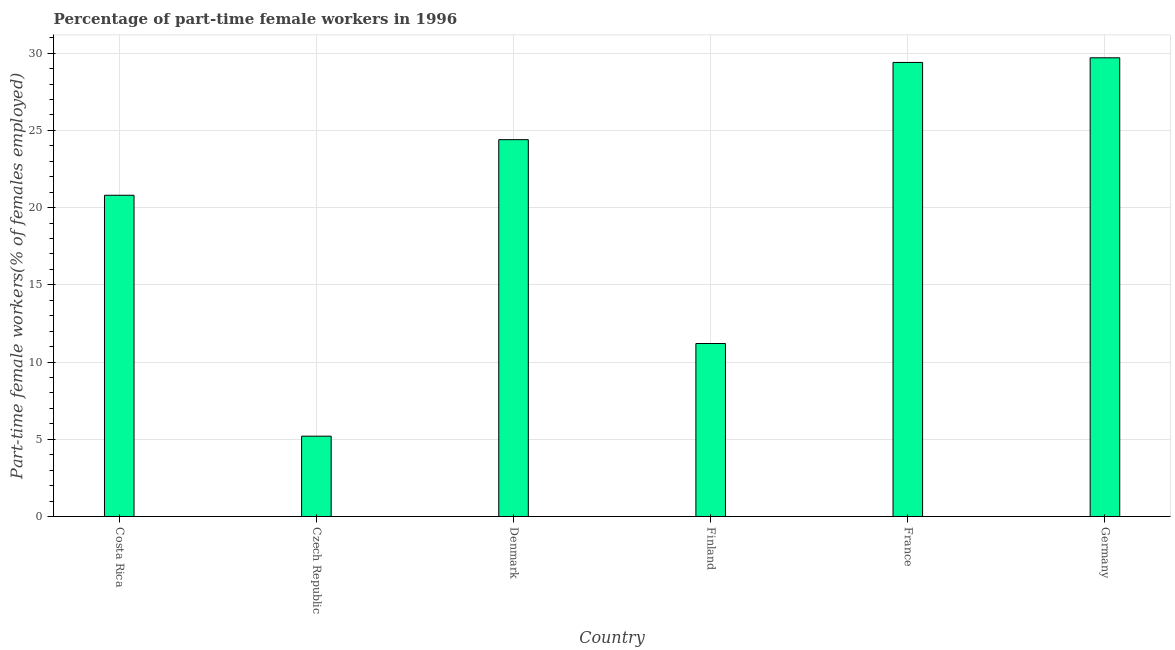What is the title of the graph?
Provide a succinct answer. Percentage of part-time female workers in 1996. What is the label or title of the X-axis?
Your answer should be compact. Country. What is the label or title of the Y-axis?
Your response must be concise. Part-time female workers(% of females employed). What is the percentage of part-time female workers in Czech Republic?
Your answer should be compact. 5.2. Across all countries, what is the maximum percentage of part-time female workers?
Ensure brevity in your answer.  29.7. Across all countries, what is the minimum percentage of part-time female workers?
Ensure brevity in your answer.  5.2. In which country was the percentage of part-time female workers maximum?
Provide a short and direct response. Germany. In which country was the percentage of part-time female workers minimum?
Provide a succinct answer. Czech Republic. What is the sum of the percentage of part-time female workers?
Ensure brevity in your answer.  120.7. What is the difference between the percentage of part-time female workers in Czech Republic and Finland?
Make the answer very short. -6. What is the average percentage of part-time female workers per country?
Offer a terse response. 20.12. What is the median percentage of part-time female workers?
Offer a very short reply. 22.6. In how many countries, is the percentage of part-time female workers greater than 7 %?
Ensure brevity in your answer.  5. What is the ratio of the percentage of part-time female workers in Denmark to that in Finland?
Provide a succinct answer. 2.18. Is the difference between the percentage of part-time female workers in Costa Rica and Germany greater than the difference between any two countries?
Provide a succinct answer. No. What is the difference between the highest and the second highest percentage of part-time female workers?
Your answer should be very brief. 0.3. Is the sum of the percentage of part-time female workers in Finland and Germany greater than the maximum percentage of part-time female workers across all countries?
Your answer should be very brief. Yes. In how many countries, is the percentage of part-time female workers greater than the average percentage of part-time female workers taken over all countries?
Give a very brief answer. 4. What is the Part-time female workers(% of females employed) in Costa Rica?
Keep it short and to the point. 20.8. What is the Part-time female workers(% of females employed) in Czech Republic?
Your answer should be compact. 5.2. What is the Part-time female workers(% of females employed) in Denmark?
Offer a terse response. 24.4. What is the Part-time female workers(% of females employed) of Finland?
Provide a short and direct response. 11.2. What is the Part-time female workers(% of females employed) of France?
Your answer should be very brief. 29.4. What is the Part-time female workers(% of females employed) in Germany?
Your response must be concise. 29.7. What is the difference between the Part-time female workers(% of females employed) in Costa Rica and Denmark?
Offer a very short reply. -3.6. What is the difference between the Part-time female workers(% of females employed) in Costa Rica and Finland?
Your answer should be very brief. 9.6. What is the difference between the Part-time female workers(% of females employed) in Czech Republic and Denmark?
Provide a short and direct response. -19.2. What is the difference between the Part-time female workers(% of females employed) in Czech Republic and Finland?
Your response must be concise. -6. What is the difference between the Part-time female workers(% of females employed) in Czech Republic and France?
Make the answer very short. -24.2. What is the difference between the Part-time female workers(% of females employed) in Czech Republic and Germany?
Keep it short and to the point. -24.5. What is the difference between the Part-time female workers(% of females employed) in Denmark and France?
Provide a short and direct response. -5. What is the difference between the Part-time female workers(% of females employed) in Finland and France?
Offer a very short reply. -18.2. What is the difference between the Part-time female workers(% of females employed) in Finland and Germany?
Offer a very short reply. -18.5. What is the ratio of the Part-time female workers(% of females employed) in Costa Rica to that in Denmark?
Ensure brevity in your answer.  0.85. What is the ratio of the Part-time female workers(% of females employed) in Costa Rica to that in Finland?
Keep it short and to the point. 1.86. What is the ratio of the Part-time female workers(% of females employed) in Costa Rica to that in France?
Give a very brief answer. 0.71. What is the ratio of the Part-time female workers(% of females employed) in Czech Republic to that in Denmark?
Keep it short and to the point. 0.21. What is the ratio of the Part-time female workers(% of females employed) in Czech Republic to that in Finland?
Your answer should be compact. 0.46. What is the ratio of the Part-time female workers(% of females employed) in Czech Republic to that in France?
Make the answer very short. 0.18. What is the ratio of the Part-time female workers(% of females employed) in Czech Republic to that in Germany?
Make the answer very short. 0.17. What is the ratio of the Part-time female workers(% of females employed) in Denmark to that in Finland?
Offer a terse response. 2.18. What is the ratio of the Part-time female workers(% of females employed) in Denmark to that in France?
Ensure brevity in your answer.  0.83. What is the ratio of the Part-time female workers(% of females employed) in Denmark to that in Germany?
Provide a succinct answer. 0.82. What is the ratio of the Part-time female workers(% of females employed) in Finland to that in France?
Make the answer very short. 0.38. What is the ratio of the Part-time female workers(% of females employed) in Finland to that in Germany?
Provide a short and direct response. 0.38. What is the ratio of the Part-time female workers(% of females employed) in France to that in Germany?
Provide a short and direct response. 0.99. 